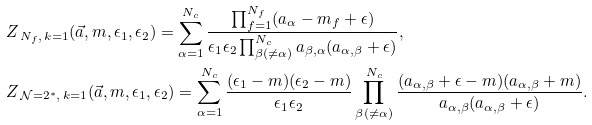Convert formula to latex. <formula><loc_0><loc_0><loc_500><loc_500>& Z _ { \, N _ { f } , \, k = 1 } ( \vec { a } , m , \epsilon _ { 1 } , \epsilon _ { 2 } ) = \sum _ { \alpha = 1 } ^ { N _ { c } } \frac { \prod _ { f = 1 } ^ { N _ { f } } ( a _ { \alpha } - m _ { f } + \epsilon ) } { \epsilon _ { 1 } \epsilon _ { 2 } \prod _ { \beta ( \neq \alpha ) } ^ { N _ { c } } a _ { \beta , \alpha } ( a _ { \alpha , \beta } + \epsilon ) } , \\ & Z _ { \, \mathcal { N } = 2 ^ { * } , \, k = 1 } ( \vec { a } , m , \epsilon _ { 1 } , \epsilon _ { 2 } ) = \sum _ { \alpha = 1 } ^ { N _ { c } } \frac { ( \epsilon _ { 1 } - m ) ( \epsilon _ { 2 } - m ) } { \epsilon _ { 1 } \epsilon _ { 2 } } \prod _ { \beta ( \neq \alpha ) } ^ { N _ { c } } \frac { ( a _ { \alpha , \beta } + \epsilon - m ) ( a _ { \alpha , \beta } + m ) } { a _ { \alpha , \beta } ( a _ { \alpha , \beta } + \epsilon ) } .</formula> 